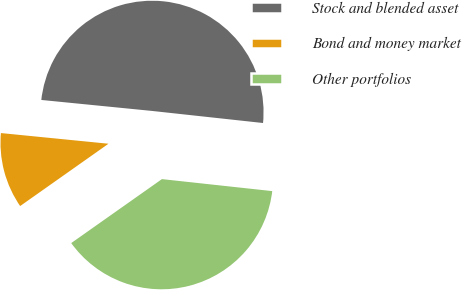Convert chart to OTSL. <chart><loc_0><loc_0><loc_500><loc_500><pie_chart><fcel>Stock and blended asset<fcel>Bond and money market<fcel>Other portfolios<nl><fcel>50.15%<fcel>11.35%<fcel>38.5%<nl></chart> 